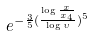<formula> <loc_0><loc_0><loc_500><loc_500>e ^ { - \frac { 3 } { 5 } ( \frac { \log \frac { x } { x _ { 4 } } } { \log \upsilon } ) ^ { 5 } }</formula> 